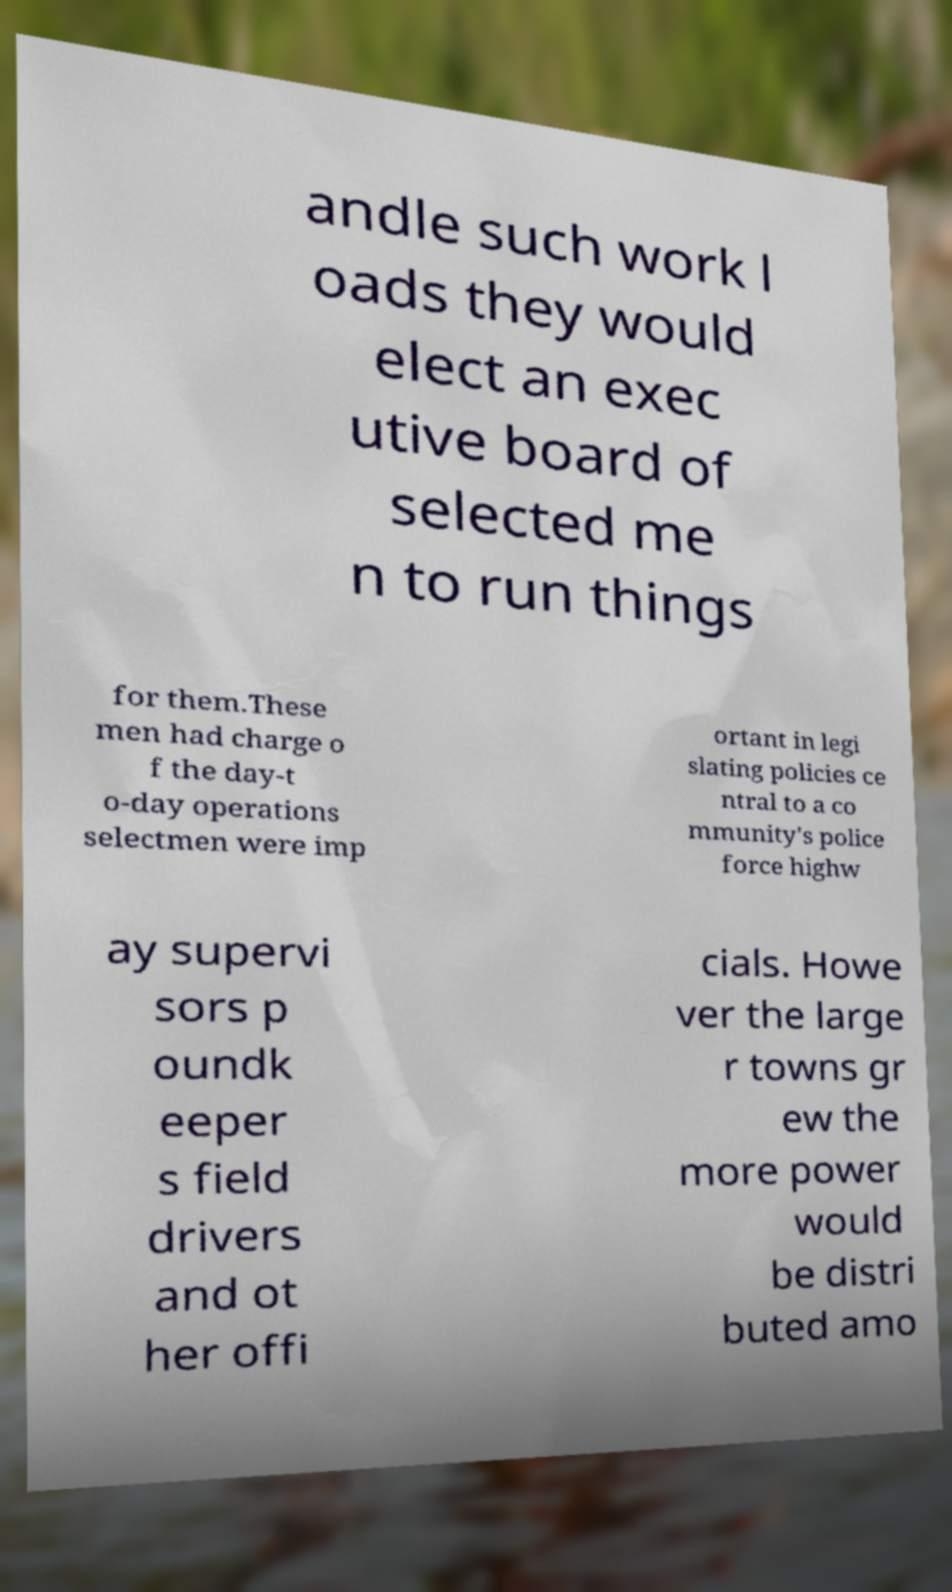Could you assist in decoding the text presented in this image and type it out clearly? andle such work l oads they would elect an exec utive board of selected me n to run things for them.These men had charge o f the day-t o-day operations selectmen were imp ortant in legi slating policies ce ntral to a co mmunity's police force highw ay supervi sors p oundk eeper s field drivers and ot her offi cials. Howe ver the large r towns gr ew the more power would be distri buted amo 